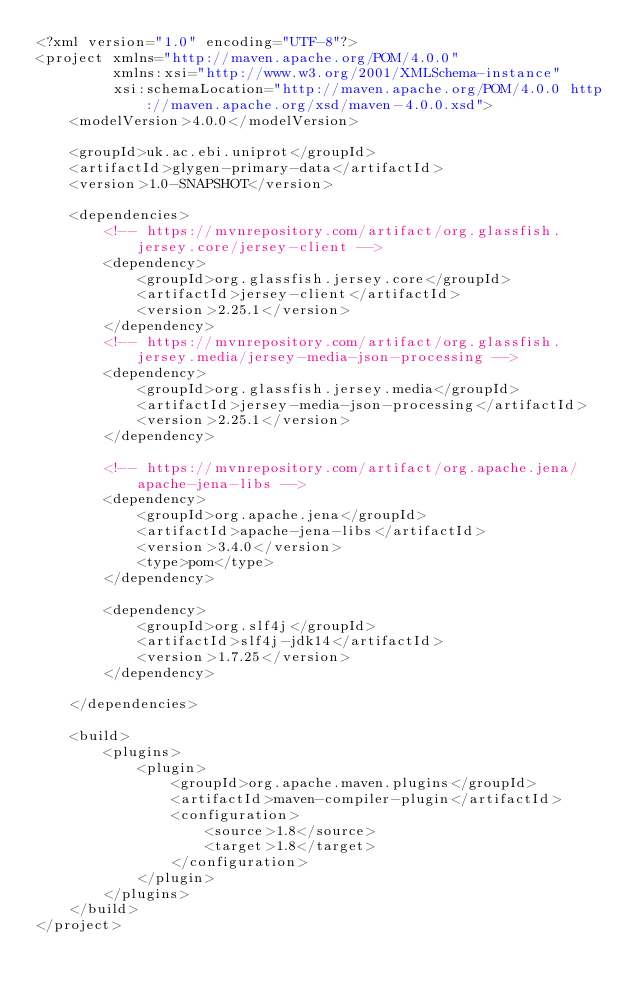<code> <loc_0><loc_0><loc_500><loc_500><_XML_><?xml version="1.0" encoding="UTF-8"?>
<project xmlns="http://maven.apache.org/POM/4.0.0"
         xmlns:xsi="http://www.w3.org/2001/XMLSchema-instance"
         xsi:schemaLocation="http://maven.apache.org/POM/4.0.0 http://maven.apache.org/xsd/maven-4.0.0.xsd">
    <modelVersion>4.0.0</modelVersion>

    <groupId>uk.ac.ebi.uniprot</groupId>
    <artifactId>glygen-primary-data</artifactId>
    <version>1.0-SNAPSHOT</version>

    <dependencies>
        <!-- https://mvnrepository.com/artifact/org.glassfish.jersey.core/jersey-client -->
        <dependency>
            <groupId>org.glassfish.jersey.core</groupId>
            <artifactId>jersey-client</artifactId>
            <version>2.25.1</version>
        </dependency>
        <!-- https://mvnrepository.com/artifact/org.glassfish.jersey.media/jersey-media-json-processing -->
        <dependency>
            <groupId>org.glassfish.jersey.media</groupId>
            <artifactId>jersey-media-json-processing</artifactId>
            <version>2.25.1</version>
        </dependency>

        <!-- https://mvnrepository.com/artifact/org.apache.jena/apache-jena-libs -->
        <dependency>
            <groupId>org.apache.jena</groupId>
            <artifactId>apache-jena-libs</artifactId>
            <version>3.4.0</version>
            <type>pom</type>
        </dependency>

        <dependency>
            <groupId>org.slf4j</groupId>
            <artifactId>slf4j-jdk14</artifactId>
            <version>1.7.25</version>
        </dependency>

    </dependencies>

    <build>
        <plugins>
            <plugin>
                <groupId>org.apache.maven.plugins</groupId>
                <artifactId>maven-compiler-plugin</artifactId>
                <configuration>
                    <source>1.8</source>
                    <target>1.8</target>
                </configuration>
            </plugin>
        </plugins>
    </build>
</project></code> 